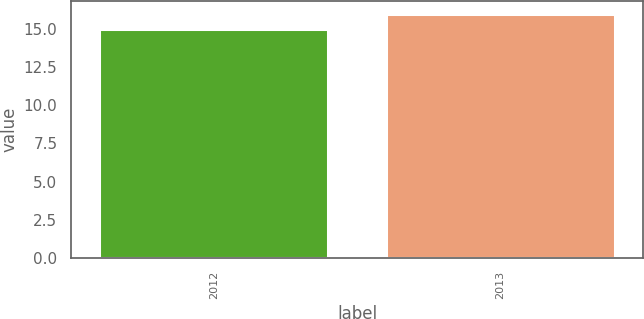<chart> <loc_0><loc_0><loc_500><loc_500><bar_chart><fcel>2012<fcel>2013<nl><fcel>15<fcel>16<nl></chart> 